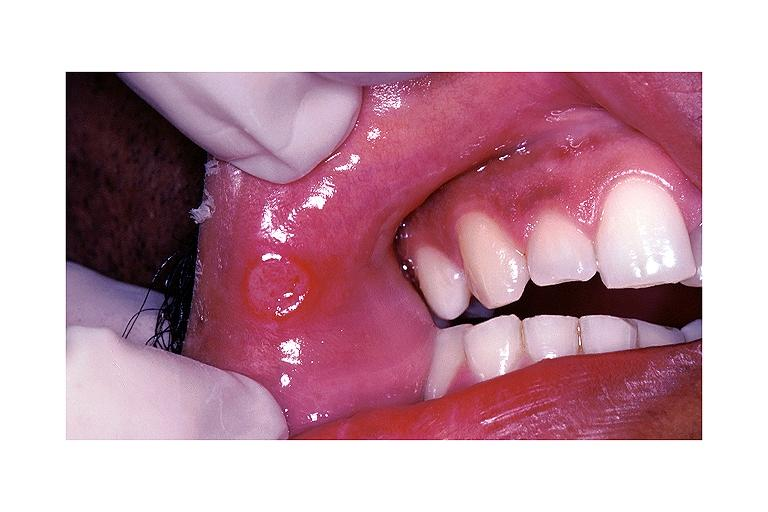s oral present?
Answer the question using a single word or phrase. Yes 